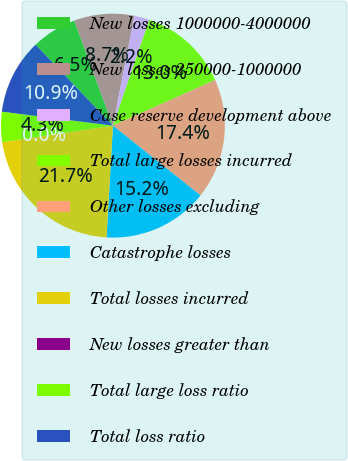Convert chart. <chart><loc_0><loc_0><loc_500><loc_500><pie_chart><fcel>New losses 1000000-4000000<fcel>New losses 250000-1000000<fcel>Case reserve development above<fcel>Total large losses incurred<fcel>Other losses excluding<fcel>Catastrophe losses<fcel>Total losses incurred<fcel>New losses greater than<fcel>Total large loss ratio<fcel>Total loss ratio<nl><fcel>6.53%<fcel>8.7%<fcel>2.18%<fcel>13.04%<fcel>17.38%<fcel>15.21%<fcel>21.73%<fcel>0.01%<fcel>4.35%<fcel>10.87%<nl></chart> 